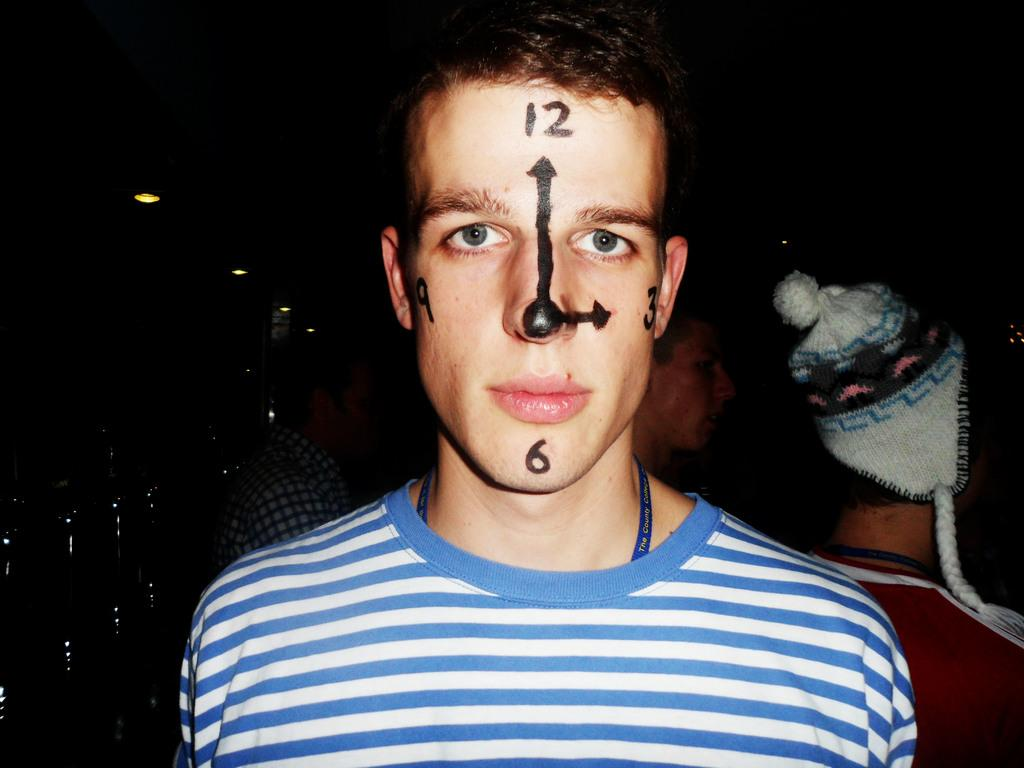Who is the main subject in the image? There is a man in the middle of the image. What is the color of the background in the image? The background of the image is dark. Can you describe the people visible in the image? There are people visible in the image, but their specific features are not mentioned in the provided facts. What can be seen in addition to the people in the image? Lights are present in the image. Where is the spot where the snakes are gathered in the image? There are no snakes present in the image. What type of ornament is hanging from the man's neck in the image? There is no mention of an ornament in the provided facts. 